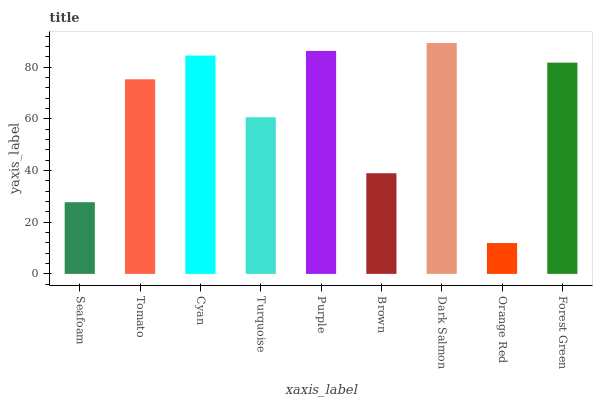Is Tomato the minimum?
Answer yes or no. No. Is Tomato the maximum?
Answer yes or no. No. Is Tomato greater than Seafoam?
Answer yes or no. Yes. Is Seafoam less than Tomato?
Answer yes or no. Yes. Is Seafoam greater than Tomato?
Answer yes or no. No. Is Tomato less than Seafoam?
Answer yes or no. No. Is Tomato the high median?
Answer yes or no. Yes. Is Tomato the low median?
Answer yes or no. Yes. Is Purple the high median?
Answer yes or no. No. Is Seafoam the low median?
Answer yes or no. No. 